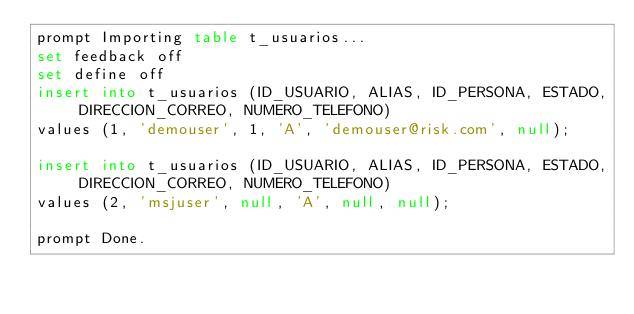Convert code to text. <code><loc_0><loc_0><loc_500><loc_500><_SQL_>prompt Importing table t_usuarios...
set feedback off
set define off
insert into t_usuarios (ID_USUARIO, ALIAS, ID_PERSONA, ESTADO, DIRECCION_CORREO, NUMERO_TELEFONO)
values (1, 'demouser', 1, 'A', 'demouser@risk.com', null);

insert into t_usuarios (ID_USUARIO, ALIAS, ID_PERSONA, ESTADO, DIRECCION_CORREO, NUMERO_TELEFONO)
values (2, 'msjuser', null, 'A', null, null);

prompt Done.
</code> 